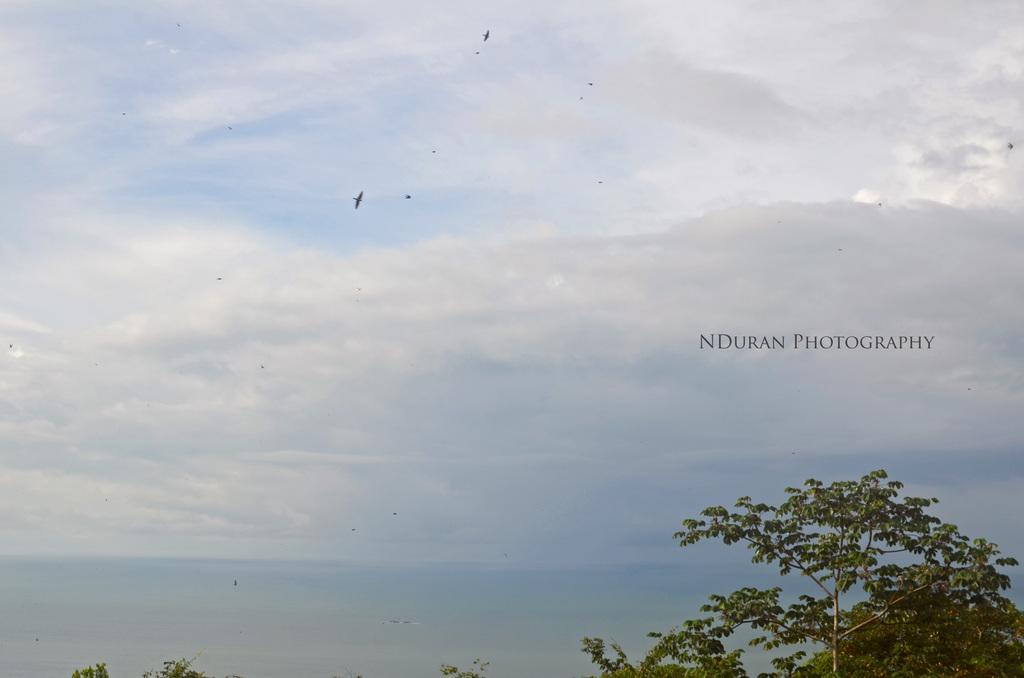What type of vegetation can be seen in the image? There are trees in the image. What is visible in the background of the image? The sky is visible in the background of the image. What can be observed in the sky? Clouds are present in the sky. What type of joke is being told by the sign in the image? There is no sign present in the image, so it is not possible to determine if a joke is being told. 